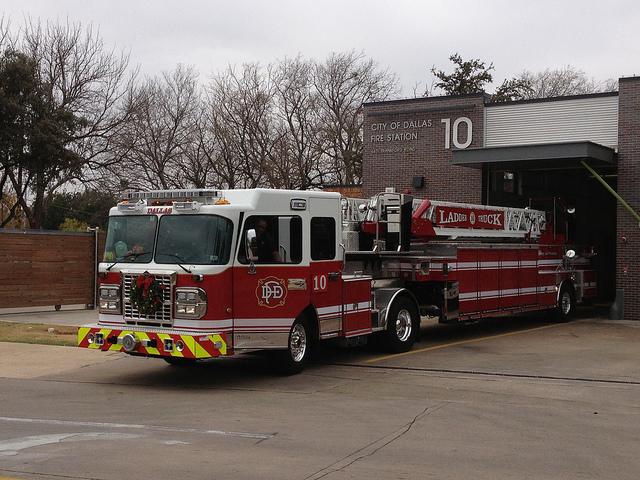Do you think this is America?
Keep it brief. Yes. How many trees are there?
Write a very short answer. 8. Where is the yellow and red striped bumper?
Give a very brief answer. Front. What number is visible in the image?
Concise answer only. 10. How many cars are in this scene?
Be succinct. 1. Is this fire hydrant leaving the station?
Keep it brief. Yes. Where is the fire department?
Give a very brief answer. Dallas. Are these people on their way to a fire?
Be succinct. Yes. Is this truck old?
Write a very short answer. No. Is this a modern fire truck?
Give a very brief answer. Yes. Are there cars in the background?
Short answer required. No. Are there lights on?
Keep it brief. No. Does the fire truck have a door open?
Be succinct. Yes. 